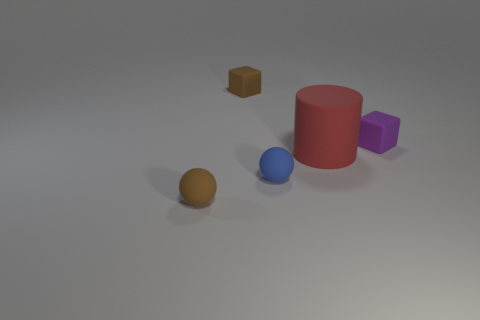Can you tell me about the lighting in this scene? The lighting in this scene is soft and diffuse, coming from a source above the objects that casts gentle shadows, thus creating a sense of depth and three-dimensionality in the setup. It seems to aim for a natural, ambient feel, much like an overcast day. 